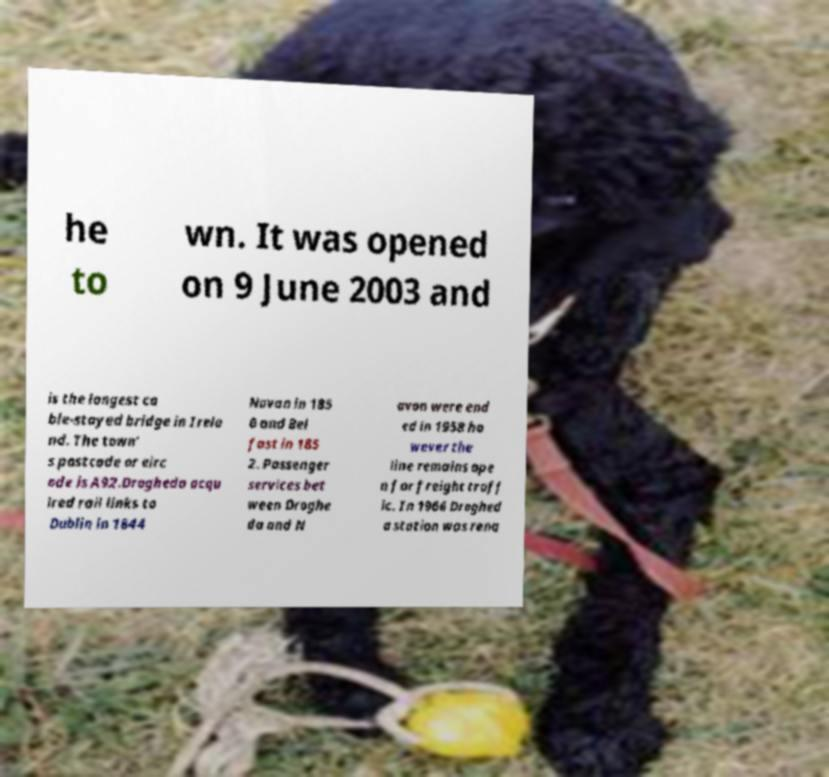Could you assist in decoding the text presented in this image and type it out clearly? he to wn. It was opened on 9 June 2003 and is the longest ca ble-stayed bridge in Irela nd. The town' s postcode or eirc ode is A92.Drogheda acqu ired rail links to Dublin in 1844 Navan in 185 0 and Bel fast in 185 2. Passenger services bet ween Droghe da and N avan were end ed in 1958 ho wever the line remains ope n for freight traff ic. In 1966 Droghed a station was rena 